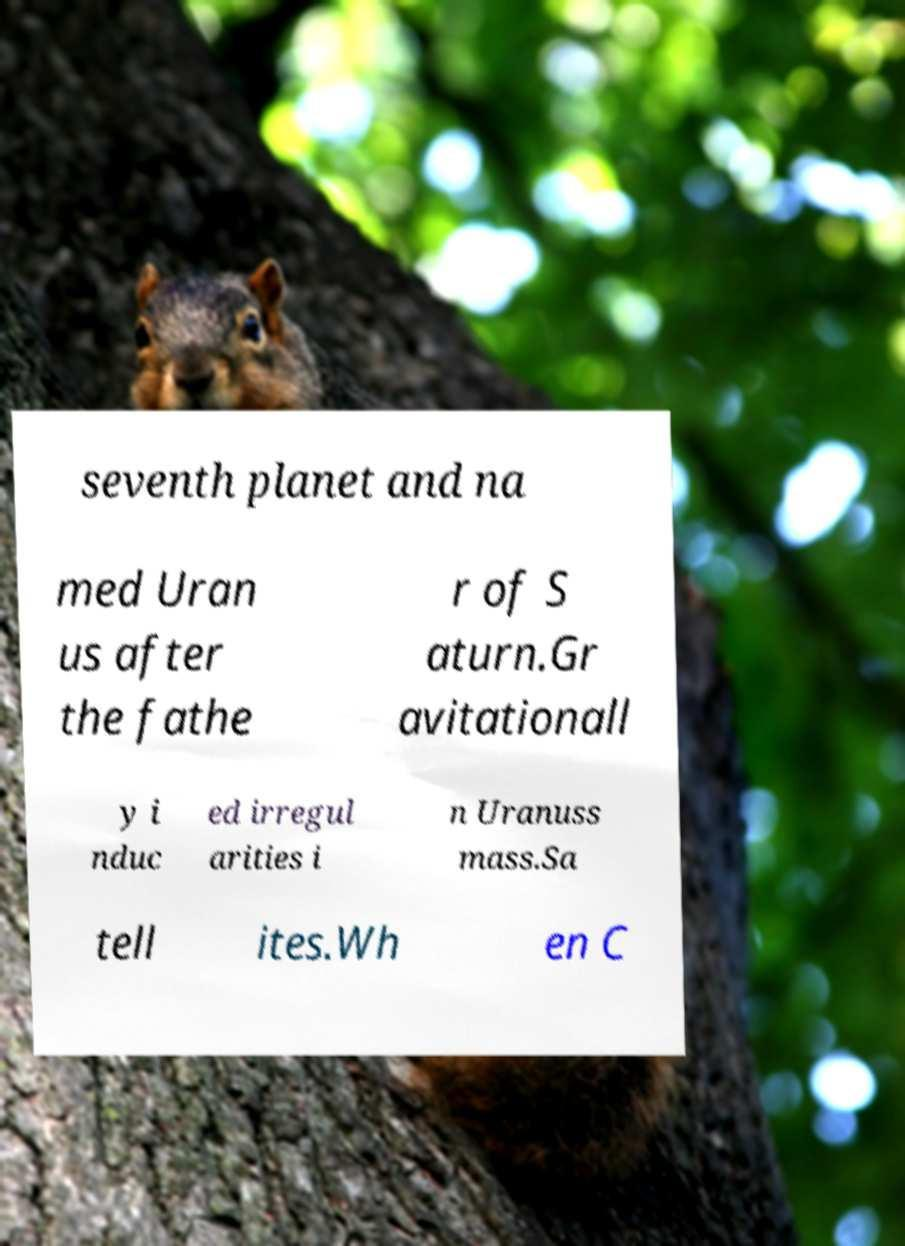There's text embedded in this image that I need extracted. Can you transcribe it verbatim? seventh planet and na med Uran us after the fathe r of S aturn.Gr avitationall y i nduc ed irregul arities i n Uranuss mass.Sa tell ites.Wh en C 